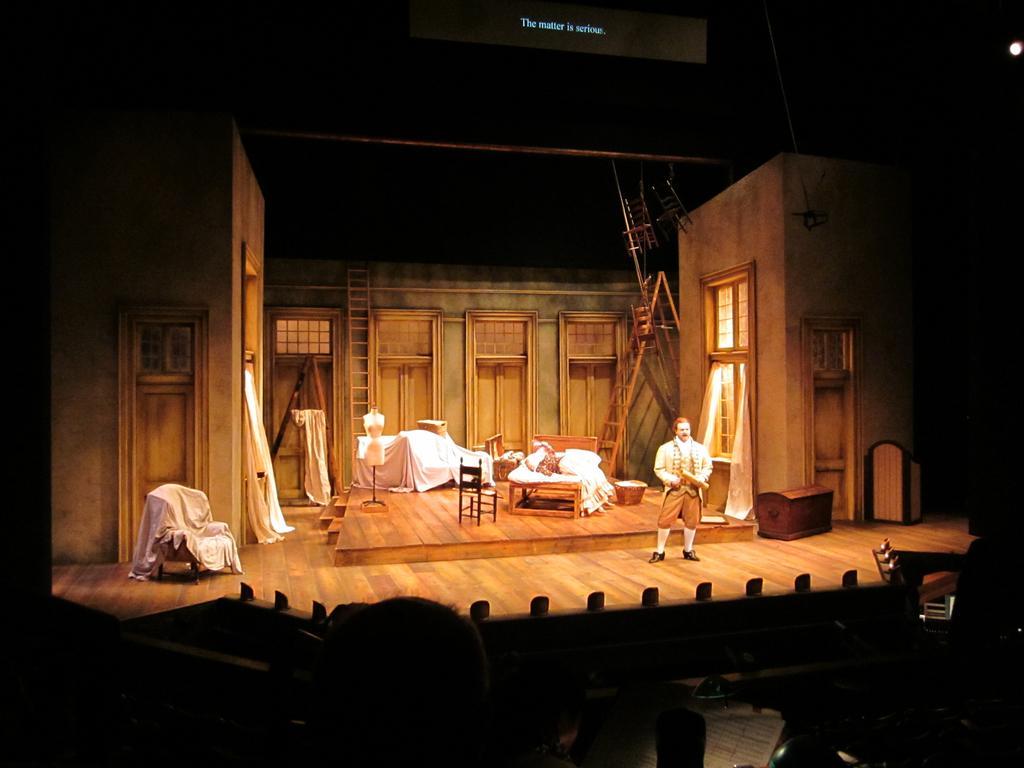Describe this image in one or two sentences. There is a person standing on a stage. On the stage there is a chair. And many other items covered with white clothes. Also there is a ladder and two chairs are hanged on the top. And there is a room with windows and door. In the back there is another ladder. There are doors. At the top something is written. 